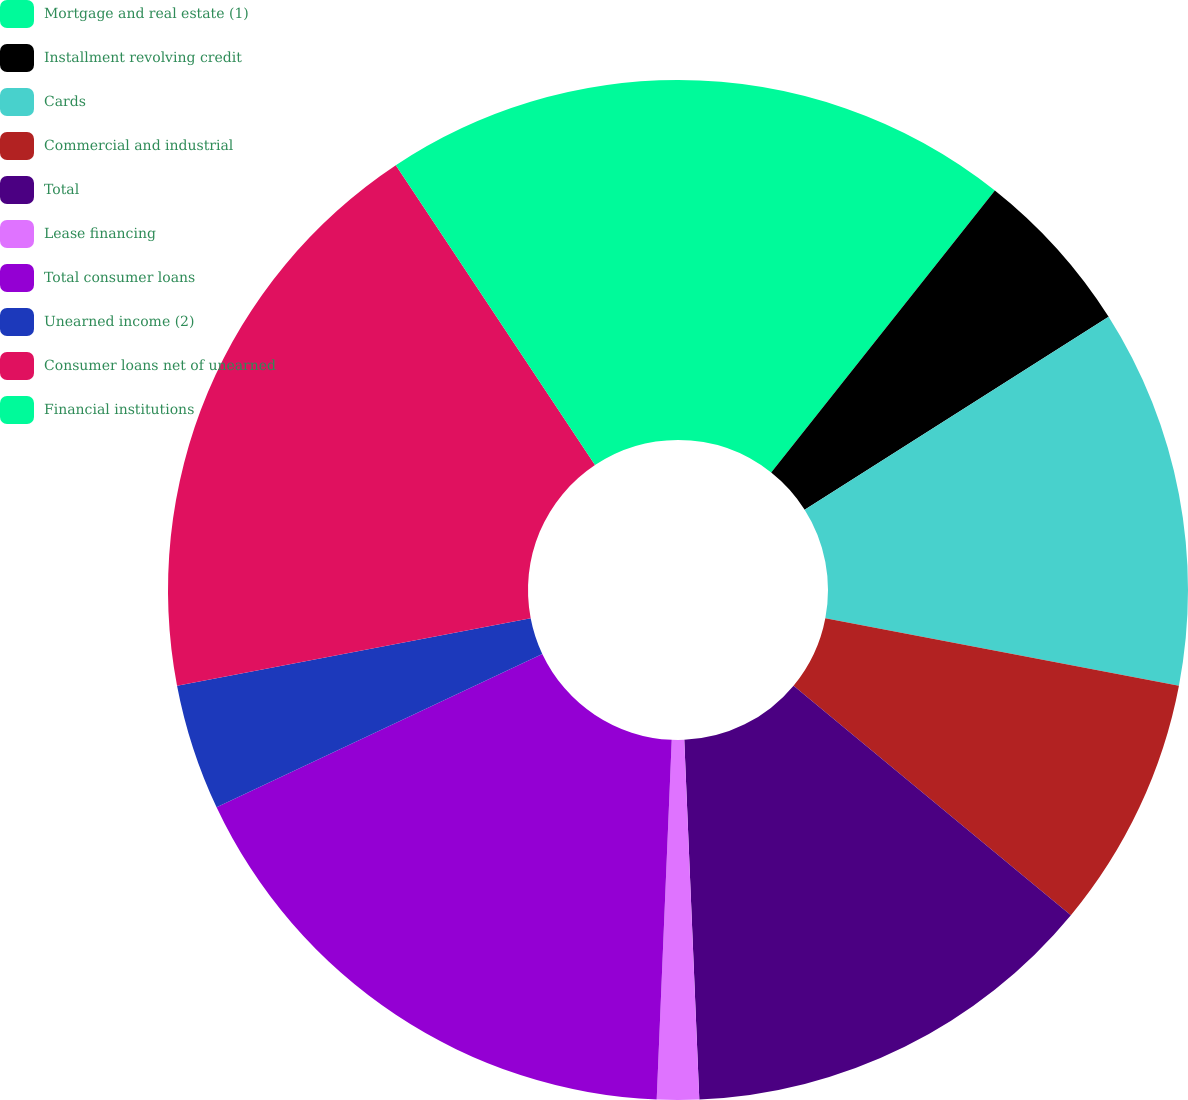Convert chart to OTSL. <chart><loc_0><loc_0><loc_500><loc_500><pie_chart><fcel>Mortgage and real estate (1)<fcel>Installment revolving credit<fcel>Cards<fcel>Commercial and industrial<fcel>Total<fcel>Lease financing<fcel>Total consumer loans<fcel>Unearned income (2)<fcel>Consumer loans net of unearned<fcel>Financial institutions<nl><fcel>10.67%<fcel>5.33%<fcel>12.0%<fcel>8.0%<fcel>13.33%<fcel>1.33%<fcel>17.33%<fcel>4.0%<fcel>18.67%<fcel>9.33%<nl></chart> 